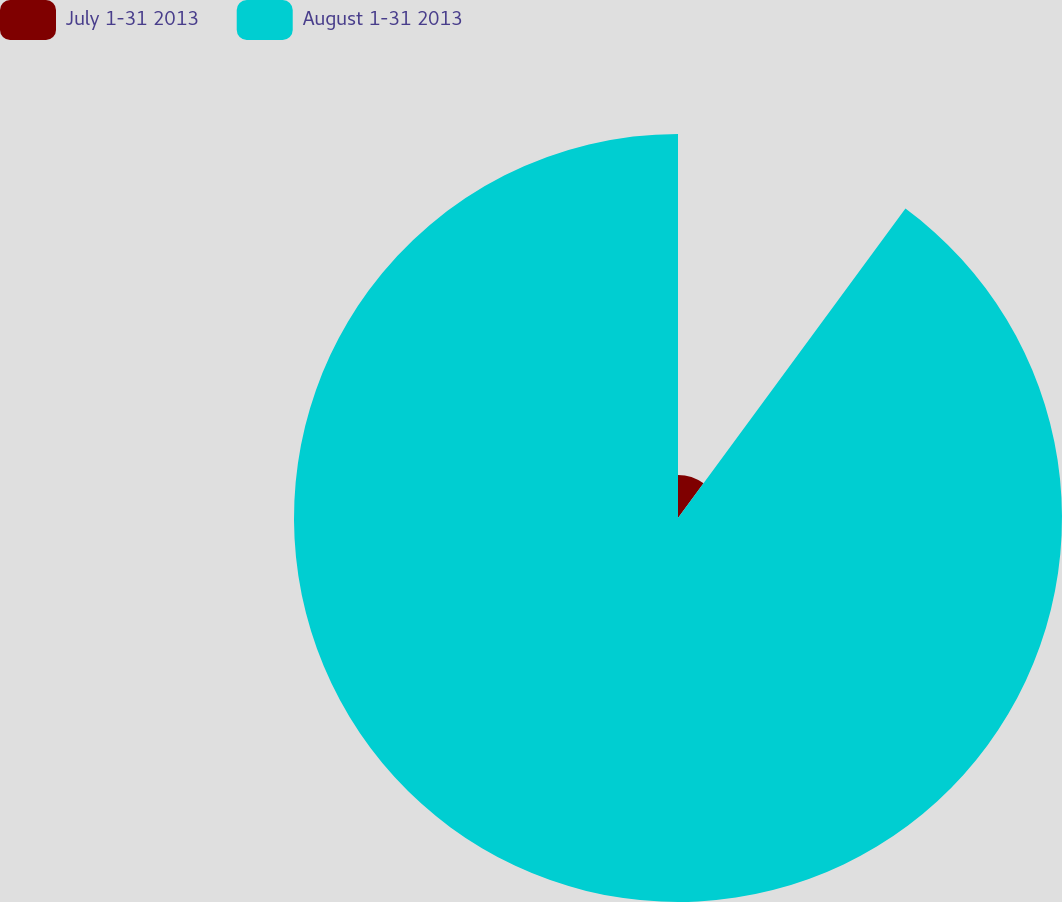Convert chart to OTSL. <chart><loc_0><loc_0><loc_500><loc_500><pie_chart><fcel>July 1-31 2013<fcel>August 1-31 2013<nl><fcel>10.09%<fcel>89.91%<nl></chart> 